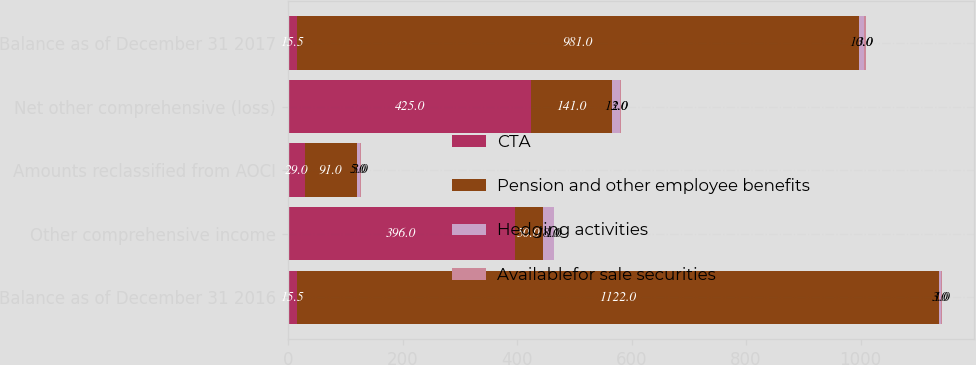<chart> <loc_0><loc_0><loc_500><loc_500><stacked_bar_chart><ecel><fcel>Balance as of December 31 2016<fcel>Other comprehensive income<fcel>Amounts reclassified from AOCI<fcel>Net other comprehensive (loss)<fcel>Balance as of December 31 2017<nl><fcel>CTA<fcel>15.5<fcel>396<fcel>29<fcel>425<fcel>15.5<nl><fcel>Pension and other employee benefits<fcel>1122<fcel>50<fcel>91<fcel>141<fcel>981<nl><fcel>Hedging activities<fcel>3<fcel>18<fcel>5<fcel>13<fcel>10<nl><fcel>Availablefor sale securities<fcel>1<fcel>1<fcel>3<fcel>2<fcel>3<nl></chart> 